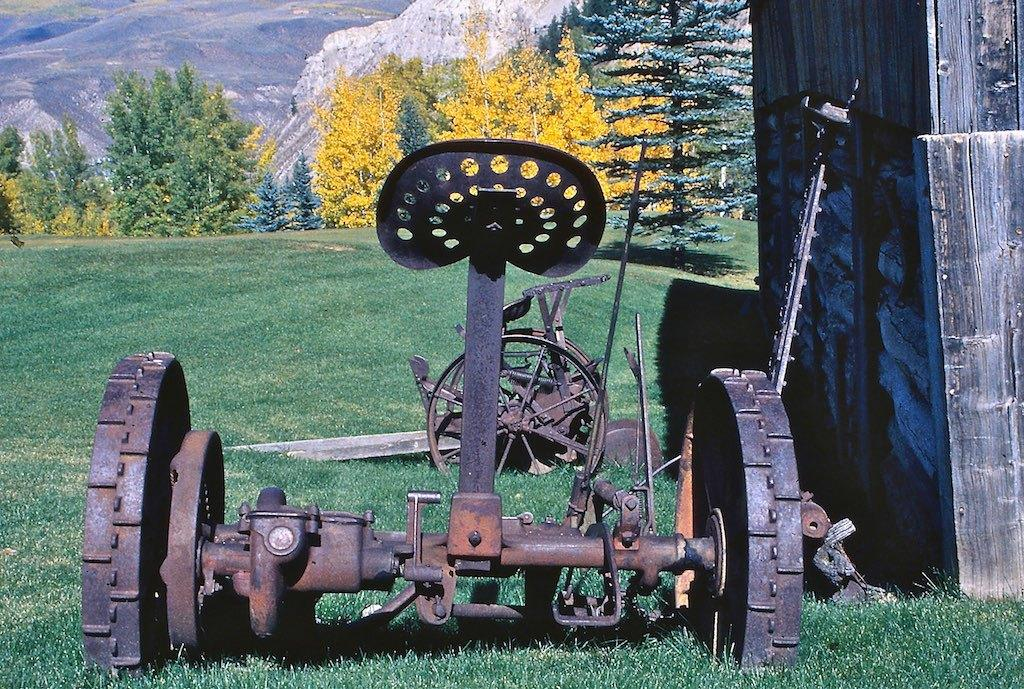What is the main subject of the image? There is a vehicle in the image. What is located near the vehicle? There is a wall in the image. What type of natural environment is visible in the image? There is grass visible in the image, and trees and a mountain are in the background. How many rings are visible on the vehicle in the image? There are no rings visible on the vehicle in the image. What type of vacation is being taken in the image? The image does not depict a vacation; it shows a vehicle, a wall, grass, trees, and a mountain. 